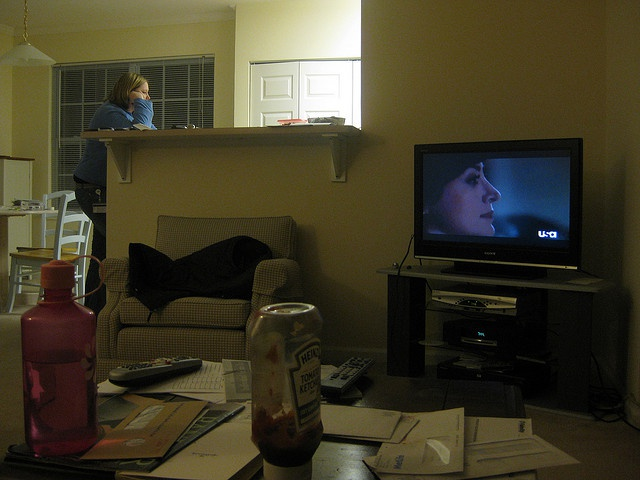Describe the objects in this image and their specific colors. I can see couch in olive, black, darkgreen, and gray tones, tv in olive, black, navy, and darkblue tones, bottle in olive, black, maroon, and gray tones, bottle in olive, black, darkgreen, and gray tones, and people in olive, black, darkgreen, and gray tones in this image. 